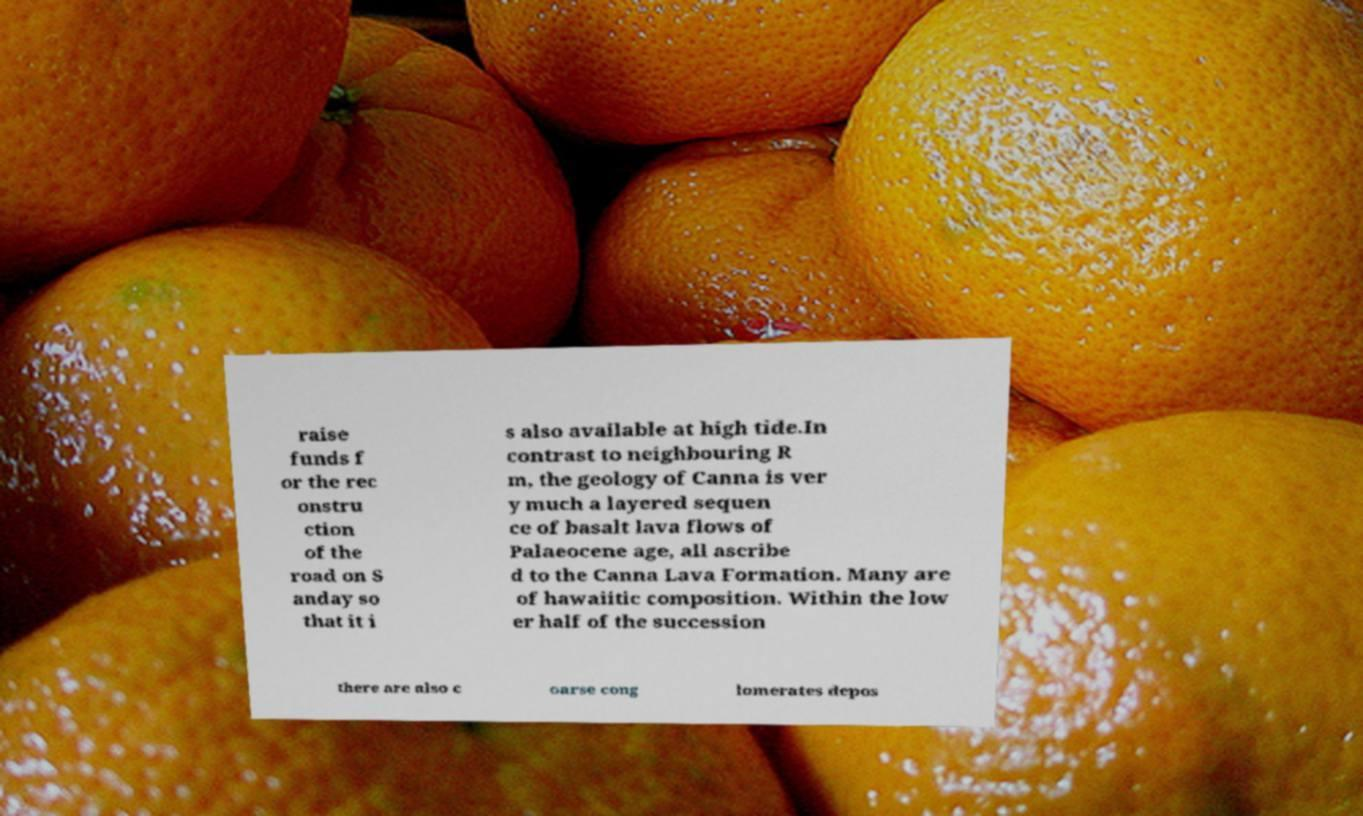Please identify and transcribe the text found in this image. raise funds f or the rec onstru ction of the road on S anday so that it i s also available at high tide.In contrast to neighbouring R m, the geology of Canna is ver y much a layered sequen ce of basalt lava flows of Palaeocene age, all ascribe d to the Canna Lava Formation. Many are of hawaiitic composition. Within the low er half of the succession there are also c oarse cong lomerates depos 